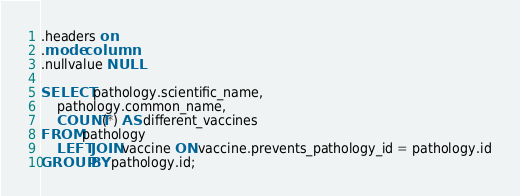Convert code to text. <code><loc_0><loc_0><loc_500><loc_500><_SQL_>.headers on
.mode column
.nullvalue NULL

SELECT pathology.scientific_name,
    pathology.common_name,
    COUNT(*) AS different_vaccines
FROM pathology
    LEFT JOIN vaccine ON vaccine.prevents_pathology_id = pathology.id
GROUP BY pathology.id;</code> 